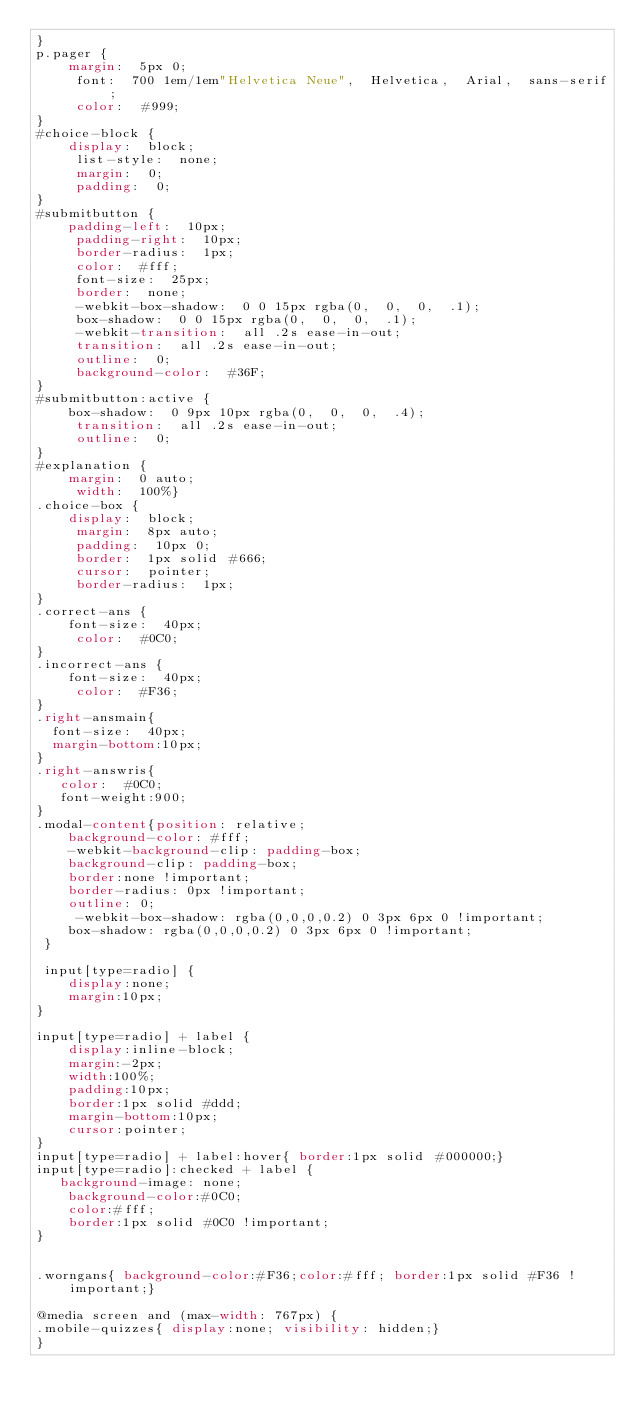Convert code to text. <code><loc_0><loc_0><loc_500><loc_500><_CSS_>}
p.pager {
    margin:  5px 0;
     font:  700 1em/1em"Helvetica Neue",  Helvetica,  Arial,  sans-serif;
     color:  #999;
}
#choice-block {
    display:  block;
     list-style:  none;
     margin:  0;
     padding:  0;
}
#submitbutton {
    padding-left:  10px;
     padding-right:  10px;
     border-radius:  1px;
     color:  #fff;
     font-size:  25px;
     border:  none;
     -webkit-box-shadow:  0 0 15px rgba(0,  0,  0,  .1);
     box-shadow:  0 0 15px rgba(0,  0,  0,  .1);
     -webkit-transition:  all .2s ease-in-out;
     transition:  all .2s ease-in-out;
     outline:  0;
     background-color:  #36F;
}
#submitbutton:active {
    box-shadow:  0 9px 10px rgba(0,  0,  0,  .4);
     transition:  all .2s ease-in-out;
     outline:  0;
}
#explanation {
    margin:  0 auto;
     width:  100%}
.choice-box {
    display:  block;
     margin:  8px auto;
     padding:  10px 0;
     border:  1px solid #666;
     cursor:  pointer;
     border-radius:  1px;
}
.correct-ans {
    font-size:  40px;
     color:  #0C0;
}
.incorrect-ans {
    font-size:  40px;
     color:  #F36;
}
.right-ansmain{
  font-size:  40px;
  margin-bottom:10px;
}
.right-answris{
   color:  #0C0;
   font-weight:900;
}
.modal-content{position: relative;
    background-color: #fff;
    -webkit-background-clip: padding-box;
    background-clip: padding-box;
	border:none !important;
    border-radius: 0px !important;
    outline: 0;
	 -webkit-box-shadow: rgba(0,0,0,0.2) 0 3px 6px 0 !important;
    box-shadow: rgba(0,0,0,0.2) 0 3px 6px 0 !important;
 }
 
 input[type=radio] {
    display:none; 
    margin:10px;
}

input[type=radio] + label {
    display:inline-block;
    margin:-2px;
	width:100%;
	padding:10px;
	border:1px solid #ddd;
	margin-bottom:10px;
	cursor:pointer;
}
input[type=radio] + label:hover{ border:1px solid #000000;}
input[type=radio]:checked + label { 
   background-image: none;
    background-color:#0C0;
	color:#fff;
	border:1px solid #0C0 !important;
}


.worngans{ background-color:#F36;color:#fff; border:1px solid #F36 !important;}

@media screen and (max-width: 767px) {
.mobile-quizzes{ display:none; visibility: hidden;}
}</code> 